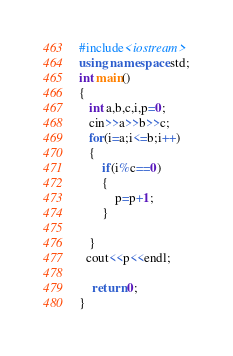<code> <loc_0><loc_0><loc_500><loc_500><_C++_>#include<iostream>
using namespace std;
int main()
{
   int a,b,c,i,p=0;
   cin>>a>>b>>c;
   for(i=a;i<=b;i++)
   {
       if(i%c==0)
       {
           p=p+1;
       }

   }
  cout<<p<<endl;

    return 0;
}
</code> 